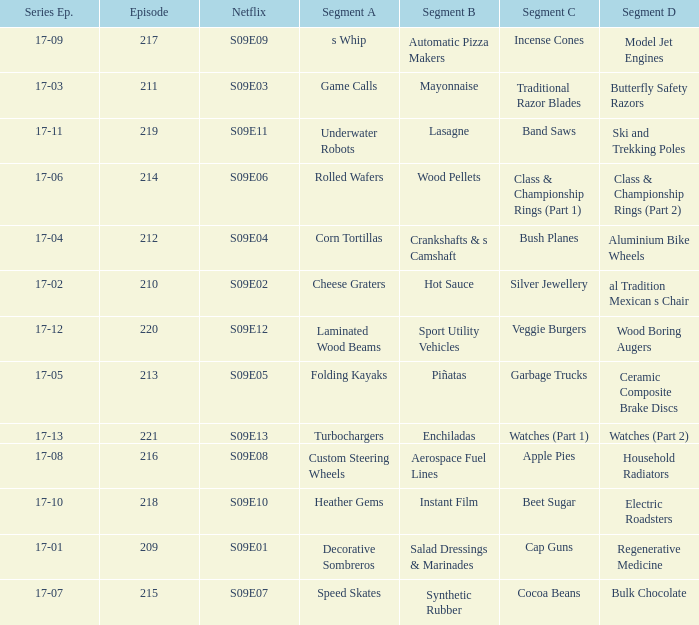Segment A of heather gems is what netflix episode? S09E10. 